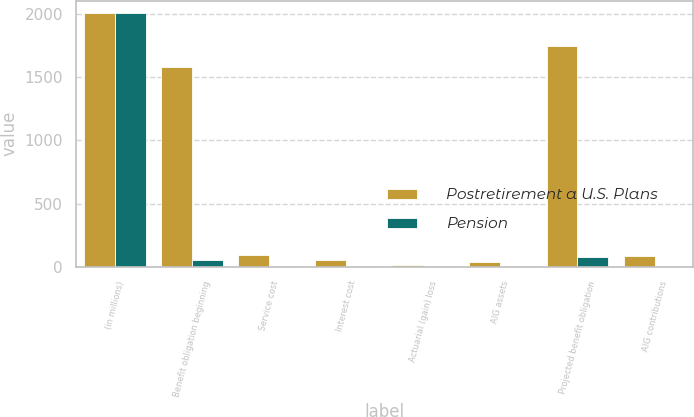Convert chart to OTSL. <chart><loc_0><loc_0><loc_500><loc_500><stacked_bar_chart><ecel><fcel>(in millions)<fcel>Benefit obligation beginning<fcel>Service cost<fcel>Interest cost<fcel>Actuarial (gain) loss<fcel>AIG assets<fcel>Projected benefit obligation<fcel>AIG contributions<nl><fcel>Postretirement a U.S. Plans<fcel>2007<fcel>1578<fcel>90<fcel>50<fcel>12<fcel>36<fcel>1745<fcel>87<nl><fcel>Pension<fcel>2007<fcel>53<fcel>5<fcel>3<fcel>2<fcel>1<fcel>79<fcel>1<nl></chart> 